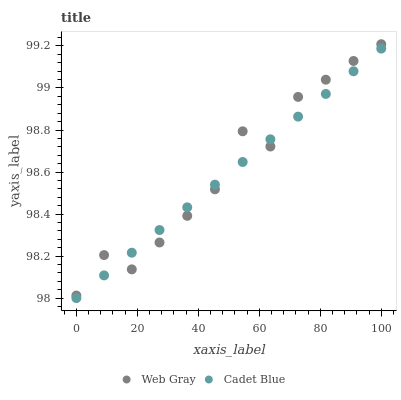Does Cadet Blue have the minimum area under the curve?
Answer yes or no. Yes. Does Web Gray have the maximum area under the curve?
Answer yes or no. Yes. Does Web Gray have the minimum area under the curve?
Answer yes or no. No. Is Cadet Blue the smoothest?
Answer yes or no. Yes. Is Web Gray the roughest?
Answer yes or no. Yes. Is Web Gray the smoothest?
Answer yes or no. No. Does Cadet Blue have the lowest value?
Answer yes or no. Yes. Does Web Gray have the lowest value?
Answer yes or no. No. Does Web Gray have the highest value?
Answer yes or no. Yes. Does Cadet Blue intersect Web Gray?
Answer yes or no. Yes. Is Cadet Blue less than Web Gray?
Answer yes or no. No. Is Cadet Blue greater than Web Gray?
Answer yes or no. No. 